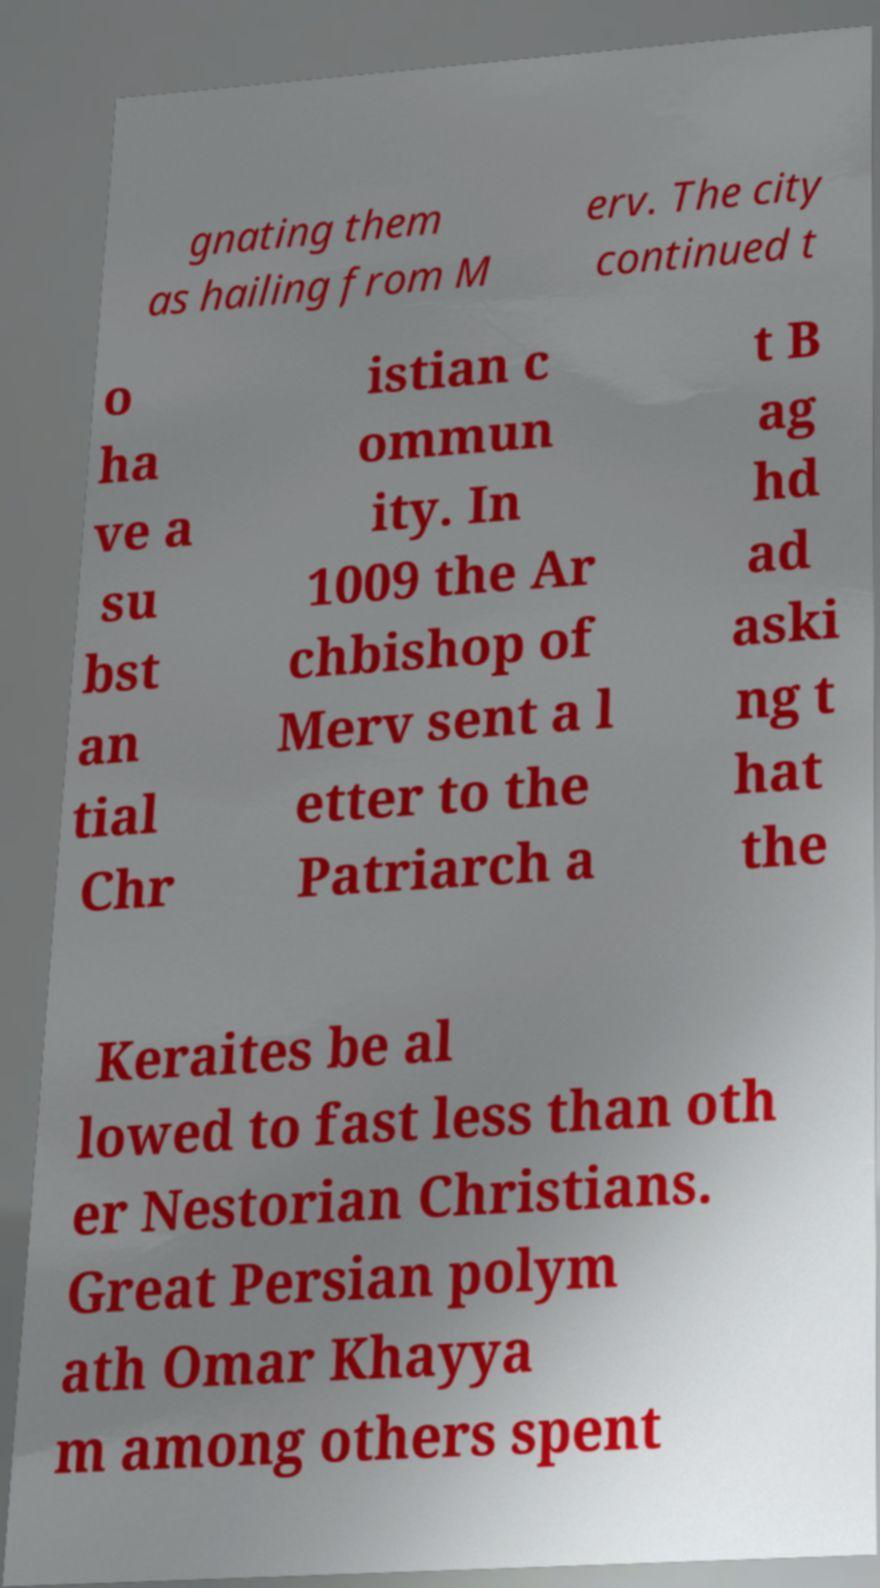Could you extract and type out the text from this image? gnating them as hailing from M erv. The city continued t o ha ve a su bst an tial Chr istian c ommun ity. In 1009 the Ar chbishop of Merv sent a l etter to the Patriarch a t B ag hd ad aski ng t hat the Keraites be al lowed to fast less than oth er Nestorian Christians. Great Persian polym ath Omar Khayya m among others spent 